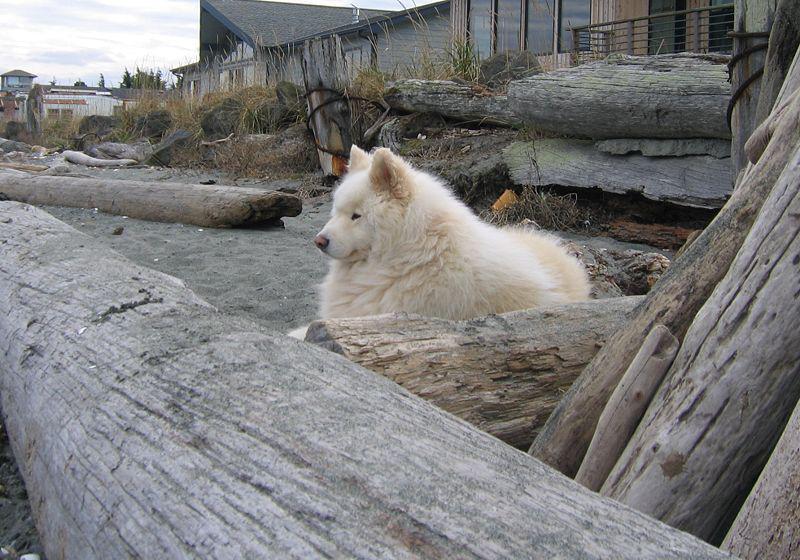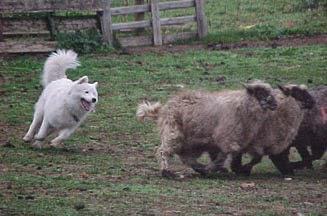The first image is the image on the left, the second image is the image on the right. For the images shown, is this caption "An image shows a white dog herding a group of sheep." true? Answer yes or no. Yes. The first image is the image on the left, the second image is the image on the right. For the images displayed, is the sentence "A white dog rounds up some sheep in one of the images." factually correct? Answer yes or no. Yes. 